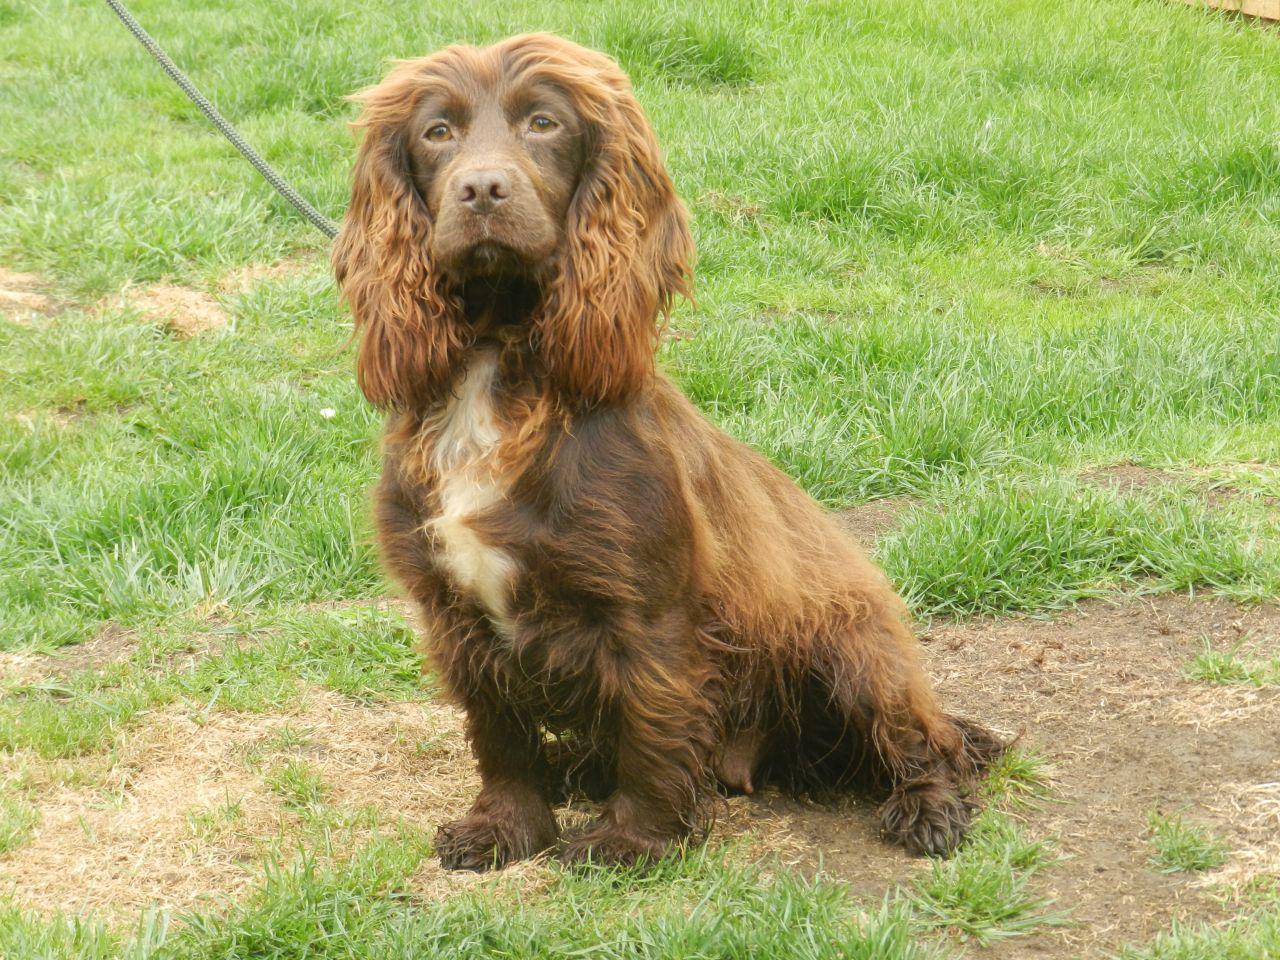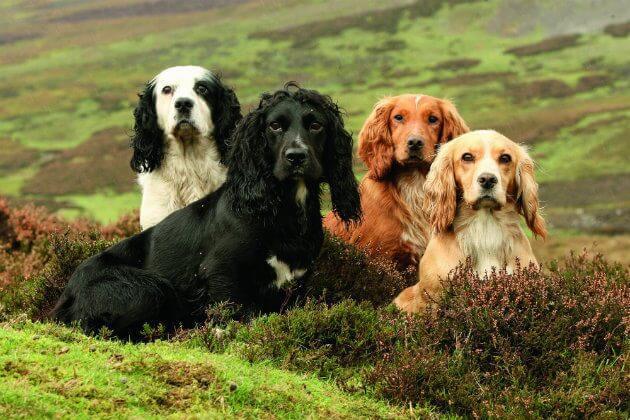The first image is the image on the left, the second image is the image on the right. Assess this claim about the two images: "The dog in the image on the left is sitting on the grass.". Correct or not? Answer yes or no. Yes. The first image is the image on the left, the second image is the image on the right. For the images shown, is this caption "One image shows a mostly gold dog sitting upright, and the other shows a dog moving forward over the grass." true? Answer yes or no. No. 